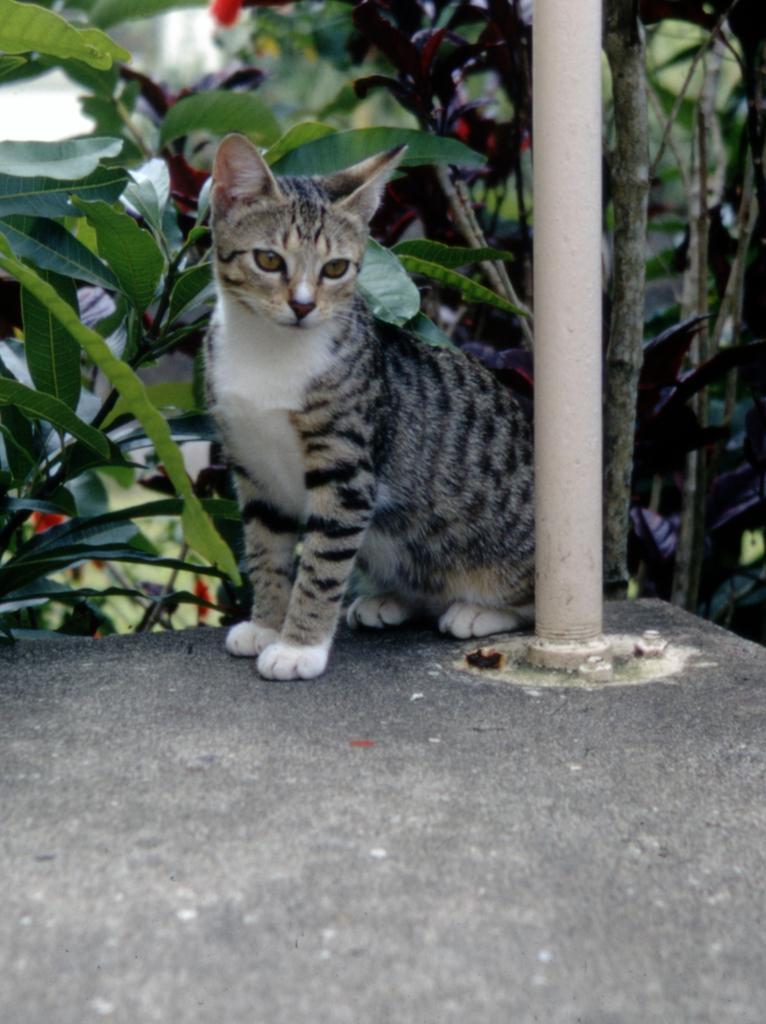Could you give a brief overview of what you see in this image? In the middle of the image we can see a cat, beside the cat we can see few plants and a metal rod. 